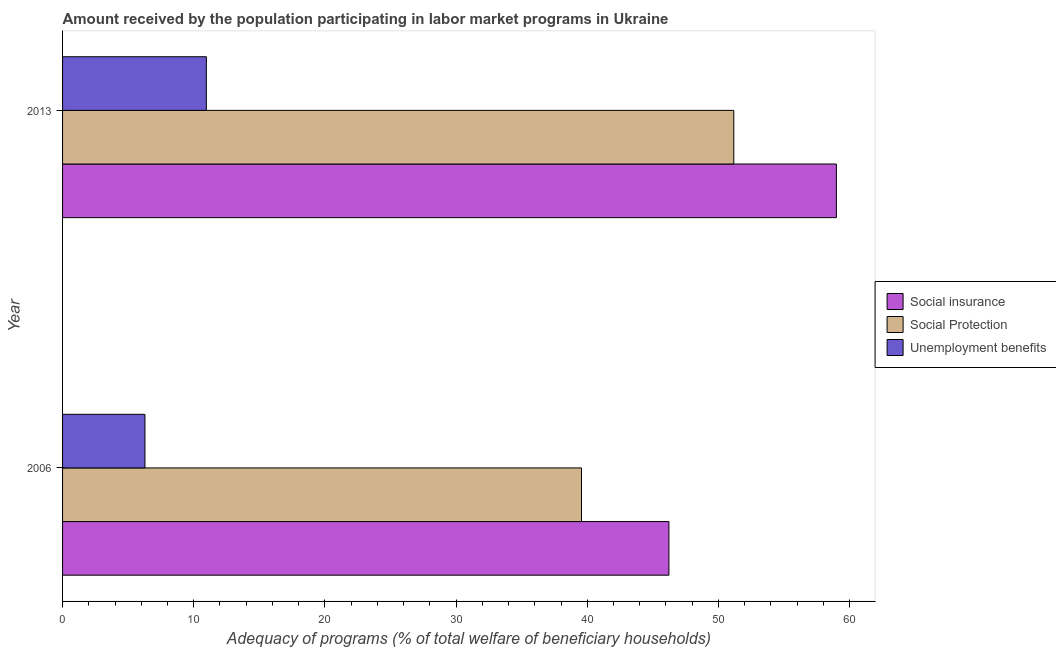How many groups of bars are there?
Your response must be concise. 2. How many bars are there on the 1st tick from the top?
Provide a short and direct response. 3. What is the amount received by the population participating in social protection programs in 2006?
Ensure brevity in your answer.  39.56. Across all years, what is the maximum amount received by the population participating in social insurance programs?
Give a very brief answer. 58.99. Across all years, what is the minimum amount received by the population participating in social protection programs?
Keep it short and to the point. 39.56. In which year was the amount received by the population participating in unemployment benefits programs maximum?
Offer a very short reply. 2013. What is the total amount received by the population participating in unemployment benefits programs in the graph?
Your answer should be compact. 17.24. What is the difference between the amount received by the population participating in social insurance programs in 2006 and that in 2013?
Your response must be concise. -12.77. What is the difference between the amount received by the population participating in social insurance programs in 2006 and the amount received by the population participating in unemployment benefits programs in 2013?
Ensure brevity in your answer.  35.26. What is the average amount received by the population participating in social insurance programs per year?
Offer a very short reply. 52.61. In the year 2013, what is the difference between the amount received by the population participating in unemployment benefits programs and amount received by the population participating in social protection programs?
Give a very brief answer. -40.21. What is the ratio of the amount received by the population participating in unemployment benefits programs in 2006 to that in 2013?
Provide a short and direct response. 0.57. Is the amount received by the population participating in social protection programs in 2006 less than that in 2013?
Keep it short and to the point. Yes. Is the difference between the amount received by the population participating in social protection programs in 2006 and 2013 greater than the difference between the amount received by the population participating in social insurance programs in 2006 and 2013?
Offer a terse response. Yes. In how many years, is the amount received by the population participating in social protection programs greater than the average amount received by the population participating in social protection programs taken over all years?
Your answer should be very brief. 1. What does the 1st bar from the top in 2006 represents?
Provide a short and direct response. Unemployment benefits. What does the 2nd bar from the bottom in 2006 represents?
Give a very brief answer. Social Protection. How many bars are there?
Keep it short and to the point. 6. Are all the bars in the graph horizontal?
Offer a terse response. Yes. How many years are there in the graph?
Ensure brevity in your answer.  2. What is the difference between two consecutive major ticks on the X-axis?
Offer a terse response. 10. Are the values on the major ticks of X-axis written in scientific E-notation?
Your response must be concise. No. Does the graph contain any zero values?
Offer a very short reply. No. How many legend labels are there?
Your answer should be very brief. 3. What is the title of the graph?
Your answer should be very brief. Amount received by the population participating in labor market programs in Ukraine. Does "Profit Tax" appear as one of the legend labels in the graph?
Give a very brief answer. No. What is the label or title of the X-axis?
Make the answer very short. Adequacy of programs (% of total welfare of beneficiary households). What is the Adequacy of programs (% of total welfare of beneficiary households) in Social insurance in 2006?
Make the answer very short. 46.23. What is the Adequacy of programs (% of total welfare of beneficiary households) of Social Protection in 2006?
Your response must be concise. 39.56. What is the Adequacy of programs (% of total welfare of beneficiary households) in Unemployment benefits in 2006?
Offer a very short reply. 6.28. What is the Adequacy of programs (% of total welfare of beneficiary households) in Social insurance in 2013?
Your answer should be compact. 58.99. What is the Adequacy of programs (% of total welfare of beneficiary households) in Social Protection in 2013?
Your response must be concise. 51.17. What is the Adequacy of programs (% of total welfare of beneficiary households) in Unemployment benefits in 2013?
Your answer should be very brief. 10.96. Across all years, what is the maximum Adequacy of programs (% of total welfare of beneficiary households) of Social insurance?
Give a very brief answer. 58.99. Across all years, what is the maximum Adequacy of programs (% of total welfare of beneficiary households) of Social Protection?
Ensure brevity in your answer.  51.17. Across all years, what is the maximum Adequacy of programs (% of total welfare of beneficiary households) of Unemployment benefits?
Provide a short and direct response. 10.96. Across all years, what is the minimum Adequacy of programs (% of total welfare of beneficiary households) in Social insurance?
Your answer should be very brief. 46.23. Across all years, what is the minimum Adequacy of programs (% of total welfare of beneficiary households) of Social Protection?
Make the answer very short. 39.56. Across all years, what is the minimum Adequacy of programs (% of total welfare of beneficiary households) in Unemployment benefits?
Offer a terse response. 6.28. What is the total Adequacy of programs (% of total welfare of beneficiary households) in Social insurance in the graph?
Make the answer very short. 105.22. What is the total Adequacy of programs (% of total welfare of beneficiary households) in Social Protection in the graph?
Your answer should be very brief. 90.73. What is the total Adequacy of programs (% of total welfare of beneficiary households) of Unemployment benefits in the graph?
Your answer should be very brief. 17.24. What is the difference between the Adequacy of programs (% of total welfare of beneficiary households) in Social insurance in 2006 and that in 2013?
Make the answer very short. -12.77. What is the difference between the Adequacy of programs (% of total welfare of beneficiary households) of Social Protection in 2006 and that in 2013?
Give a very brief answer. -11.61. What is the difference between the Adequacy of programs (% of total welfare of beneficiary households) of Unemployment benefits in 2006 and that in 2013?
Offer a very short reply. -4.68. What is the difference between the Adequacy of programs (% of total welfare of beneficiary households) of Social insurance in 2006 and the Adequacy of programs (% of total welfare of beneficiary households) of Social Protection in 2013?
Provide a short and direct response. -4.94. What is the difference between the Adequacy of programs (% of total welfare of beneficiary households) in Social insurance in 2006 and the Adequacy of programs (% of total welfare of beneficiary households) in Unemployment benefits in 2013?
Provide a succinct answer. 35.26. What is the difference between the Adequacy of programs (% of total welfare of beneficiary households) in Social Protection in 2006 and the Adequacy of programs (% of total welfare of beneficiary households) in Unemployment benefits in 2013?
Your answer should be very brief. 28.6. What is the average Adequacy of programs (% of total welfare of beneficiary households) of Social insurance per year?
Offer a terse response. 52.61. What is the average Adequacy of programs (% of total welfare of beneficiary households) in Social Protection per year?
Provide a short and direct response. 45.37. What is the average Adequacy of programs (% of total welfare of beneficiary households) in Unemployment benefits per year?
Provide a short and direct response. 8.62. In the year 2006, what is the difference between the Adequacy of programs (% of total welfare of beneficiary households) of Social insurance and Adequacy of programs (% of total welfare of beneficiary households) of Social Protection?
Keep it short and to the point. 6.66. In the year 2006, what is the difference between the Adequacy of programs (% of total welfare of beneficiary households) in Social insurance and Adequacy of programs (% of total welfare of beneficiary households) in Unemployment benefits?
Your response must be concise. 39.95. In the year 2006, what is the difference between the Adequacy of programs (% of total welfare of beneficiary households) of Social Protection and Adequacy of programs (% of total welfare of beneficiary households) of Unemployment benefits?
Offer a very short reply. 33.28. In the year 2013, what is the difference between the Adequacy of programs (% of total welfare of beneficiary households) in Social insurance and Adequacy of programs (% of total welfare of beneficiary households) in Social Protection?
Ensure brevity in your answer.  7.82. In the year 2013, what is the difference between the Adequacy of programs (% of total welfare of beneficiary households) of Social insurance and Adequacy of programs (% of total welfare of beneficiary households) of Unemployment benefits?
Your response must be concise. 48.03. In the year 2013, what is the difference between the Adequacy of programs (% of total welfare of beneficiary households) of Social Protection and Adequacy of programs (% of total welfare of beneficiary households) of Unemployment benefits?
Make the answer very short. 40.21. What is the ratio of the Adequacy of programs (% of total welfare of beneficiary households) in Social insurance in 2006 to that in 2013?
Give a very brief answer. 0.78. What is the ratio of the Adequacy of programs (% of total welfare of beneficiary households) of Social Protection in 2006 to that in 2013?
Ensure brevity in your answer.  0.77. What is the ratio of the Adequacy of programs (% of total welfare of beneficiary households) in Unemployment benefits in 2006 to that in 2013?
Ensure brevity in your answer.  0.57. What is the difference between the highest and the second highest Adequacy of programs (% of total welfare of beneficiary households) of Social insurance?
Provide a succinct answer. 12.77. What is the difference between the highest and the second highest Adequacy of programs (% of total welfare of beneficiary households) of Social Protection?
Your response must be concise. 11.61. What is the difference between the highest and the second highest Adequacy of programs (% of total welfare of beneficiary households) of Unemployment benefits?
Your answer should be very brief. 4.68. What is the difference between the highest and the lowest Adequacy of programs (% of total welfare of beneficiary households) in Social insurance?
Ensure brevity in your answer.  12.77. What is the difference between the highest and the lowest Adequacy of programs (% of total welfare of beneficiary households) of Social Protection?
Your answer should be compact. 11.61. What is the difference between the highest and the lowest Adequacy of programs (% of total welfare of beneficiary households) in Unemployment benefits?
Offer a terse response. 4.68. 